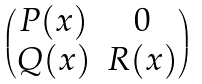Convert formula to latex. <formula><loc_0><loc_0><loc_500><loc_500>\begin{pmatrix} P ( x ) & 0 \\ Q ( x ) & R ( x ) \end{pmatrix}</formula> 